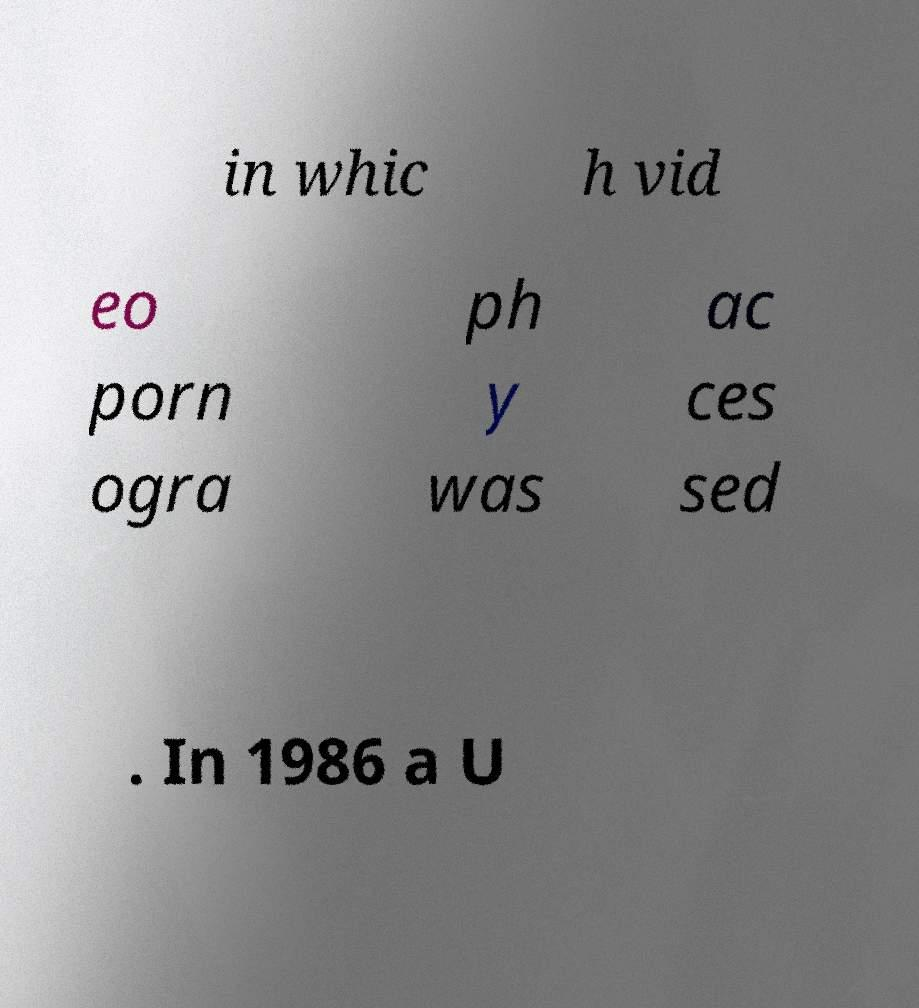Please read and relay the text visible in this image. What does it say? in whic h vid eo porn ogra ph y was ac ces sed . In 1986 a U 